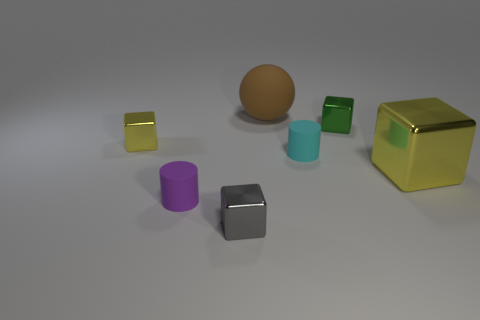Subtract all green shiny blocks. How many blocks are left? 3 Subtract all cylinders. How many objects are left? 5 Subtract 1 cylinders. How many cylinders are left? 1 Add 2 cyan matte cylinders. How many objects exist? 9 Subtract all gray cubes. How many cubes are left? 3 Subtract all purple blocks. How many blue cylinders are left? 0 Subtract all cyan objects. Subtract all small purple things. How many objects are left? 5 Add 1 rubber things. How many rubber things are left? 4 Add 6 gray metallic objects. How many gray metallic objects exist? 7 Subtract 0 red cylinders. How many objects are left? 7 